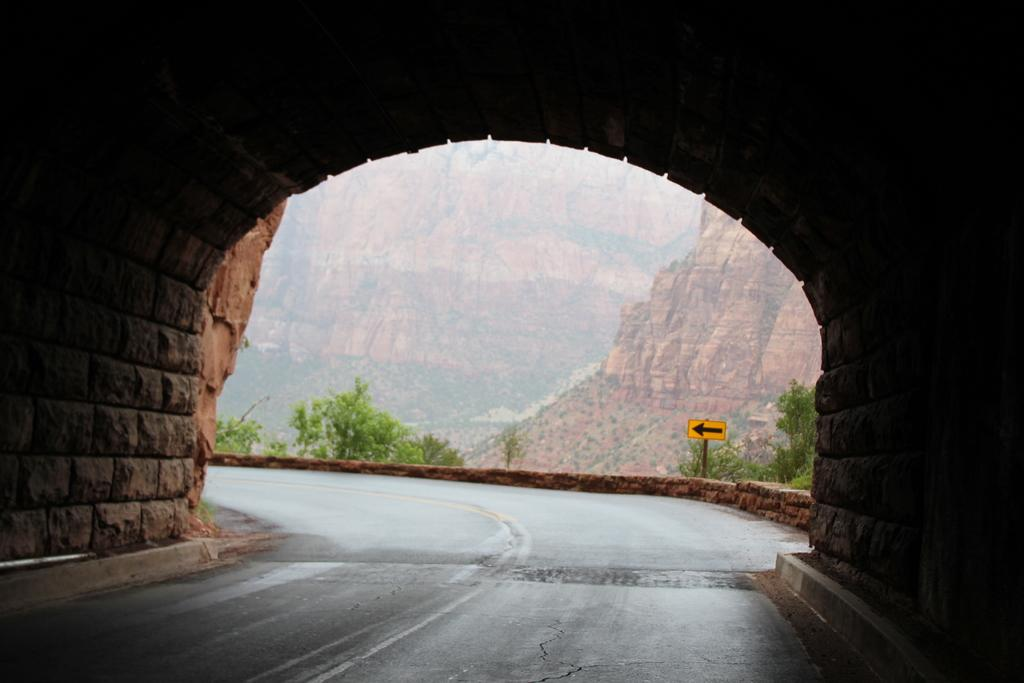What is the main feature of the image? There is a road in the image. What can be seen in the background of the image? There are plants in the background of the image, and they are green. There is also a yellow sign in the background. Can you describe any other objects in the image? Yes, there is a rock in the image, and it is brown. How does the fly contribute to the harmony of the image? There is no fly present in the image, so it cannot contribute to the harmony. 